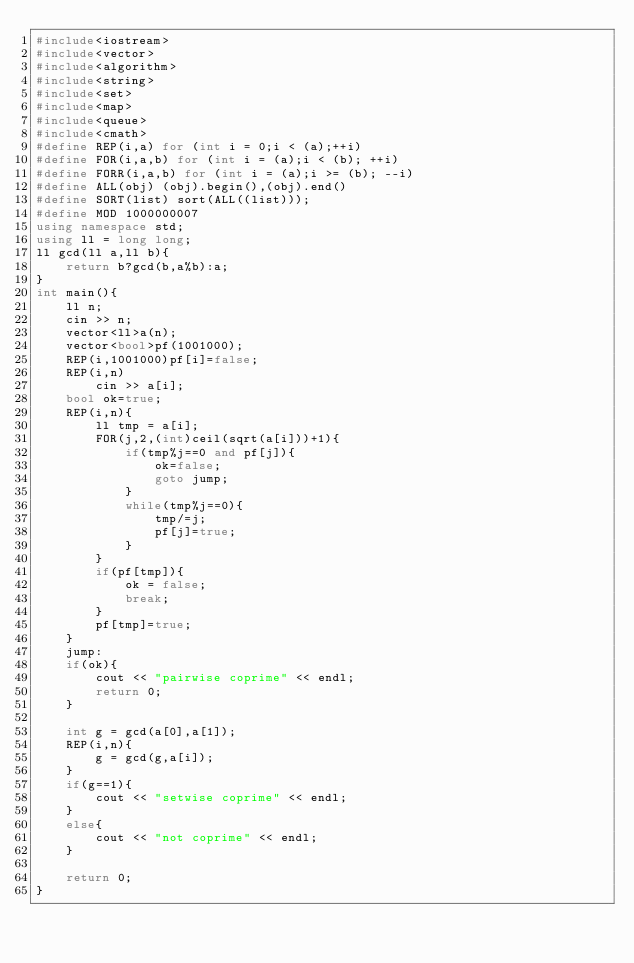<code> <loc_0><loc_0><loc_500><loc_500><_C++_>#include<iostream>
#include<vector>
#include<algorithm>
#include<string>
#include<set>
#include<map>
#include<queue>
#include<cmath>
#define REP(i,a) for (int i = 0;i < (a);++i)
#define FOR(i,a,b) for (int i = (a);i < (b); ++i)
#define FORR(i,a,b) for (int i = (a);i >= (b); --i)
#define ALL(obj) (obj).begin(),(obj).end()
#define SORT(list) sort(ALL((list)));
#define MOD 1000000007
using namespace std;
using ll = long long;
ll gcd(ll a,ll b){
    return b?gcd(b,a%b):a;
}
int main(){
    ll n;
    cin >> n;
    vector<ll>a(n);
    vector<bool>pf(1001000);
    REP(i,1001000)pf[i]=false;
    REP(i,n)
        cin >> a[i];
    bool ok=true;
    REP(i,n){
        ll tmp = a[i];
        FOR(j,2,(int)ceil(sqrt(a[i]))+1){
            if(tmp%j==0 and pf[j]){
                ok=false;
                goto jump;
            }
            while(tmp%j==0){
                tmp/=j;
                pf[j]=true;
            }
        }
        if(pf[tmp]){
            ok = false;
            break;
        }
        pf[tmp]=true;
    }
    jump:
    if(ok){
        cout << "pairwise coprime" << endl;
        return 0;
    }

    int g = gcd(a[0],a[1]);
    REP(i,n){
        g = gcd(g,a[i]);
    }
    if(g==1){
        cout << "setwise coprime" << endl;
    }
    else{
        cout << "not coprime" << endl;
    }

    return 0;
}
</code> 